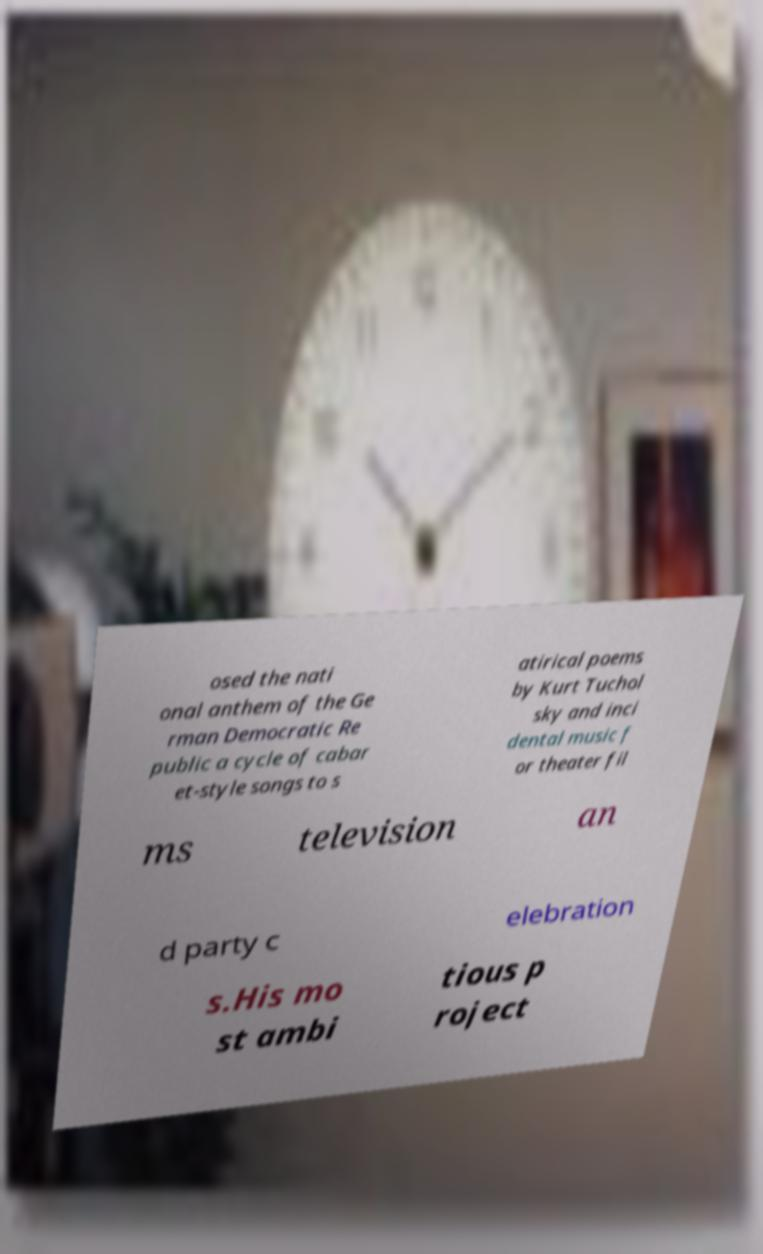Can you accurately transcribe the text from the provided image for me? osed the nati onal anthem of the Ge rman Democratic Re public a cycle of cabar et-style songs to s atirical poems by Kurt Tuchol sky and inci dental music f or theater fil ms television an d party c elebration s.His mo st ambi tious p roject 